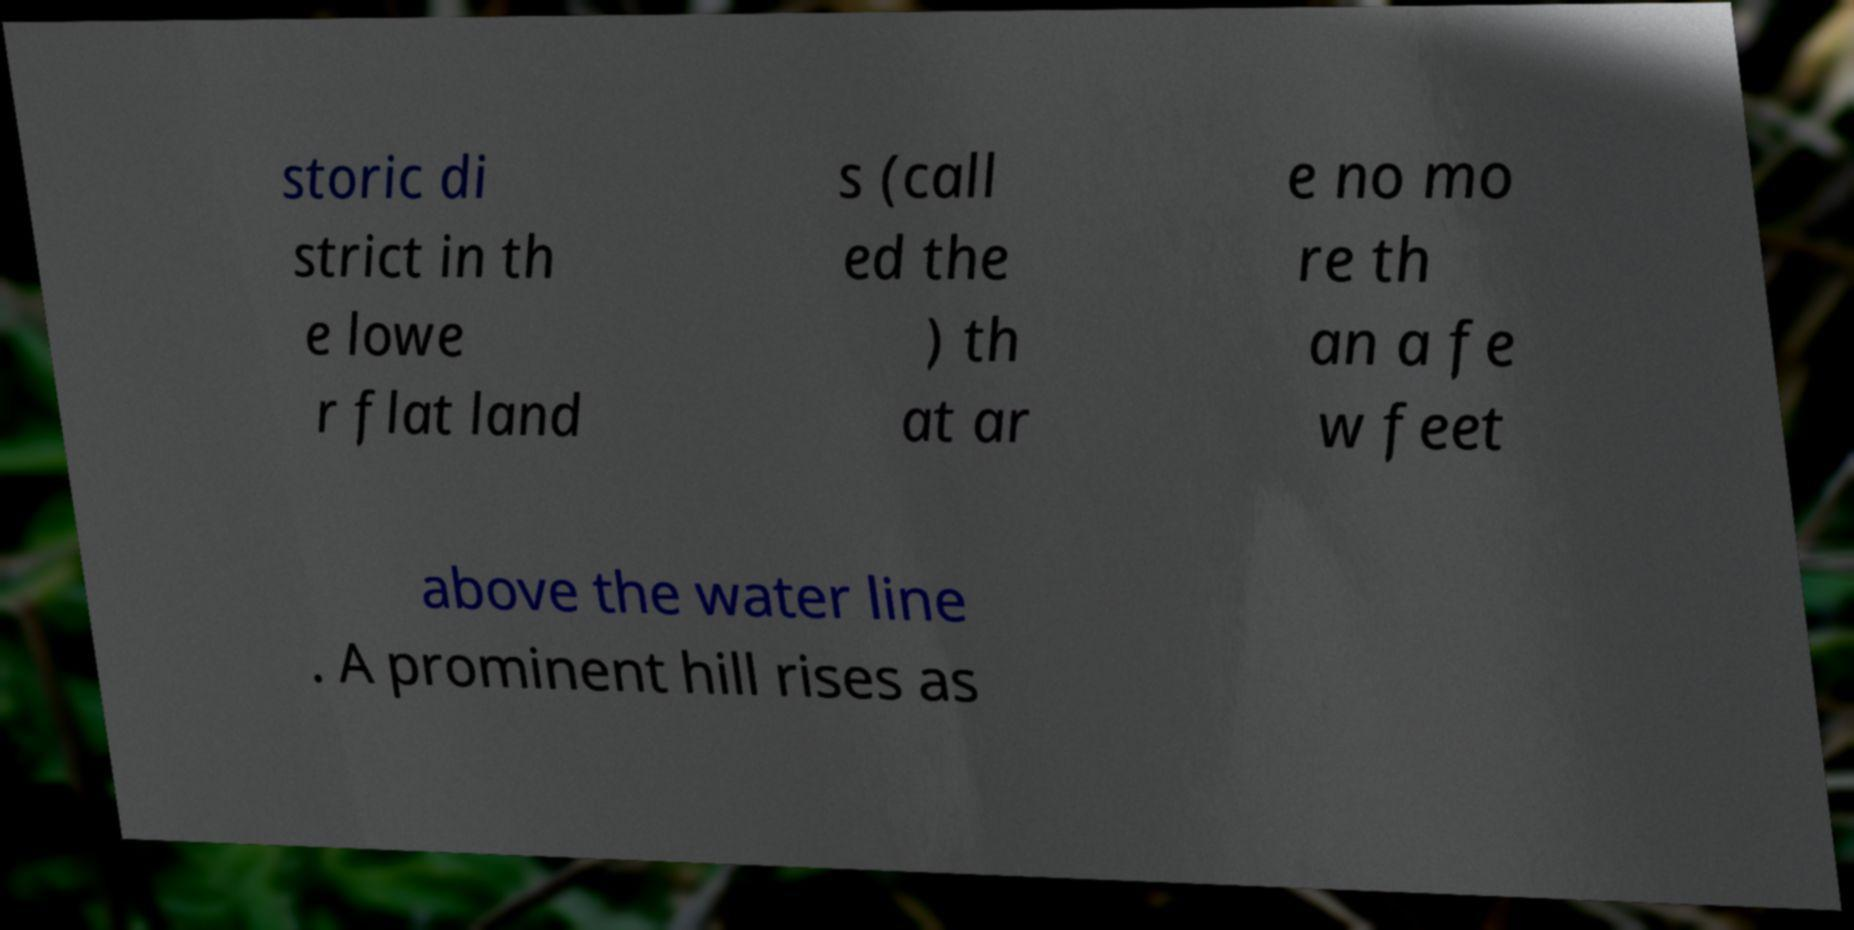Please identify and transcribe the text found in this image. storic di strict in th e lowe r flat land s (call ed the ) th at ar e no mo re th an a fe w feet above the water line . A prominent hill rises as 